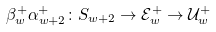Convert formula to latex. <formula><loc_0><loc_0><loc_500><loc_500>\beta _ { w } ^ { + } \alpha _ { w + 2 } ^ { + } \colon S _ { w + 2 } \to \mathcal { E } _ { w } ^ { + } \to \mathcal { U } _ { w } ^ { + }</formula> 